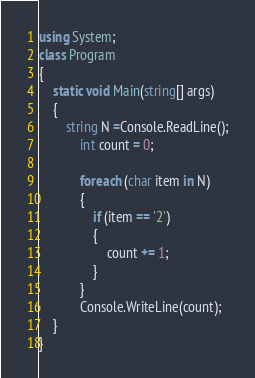<code> <loc_0><loc_0><loc_500><loc_500><_C#_>using System;
class Program
{
	static void Main(string[] args)
	{
		string N =Console.ReadLine();
            int count = 0;
            
            foreach (char item in N)
            {
                if (item == '2')
                {
                    count += 1;
                }
            }
            Console.WriteLine(count);
	}
}</code> 